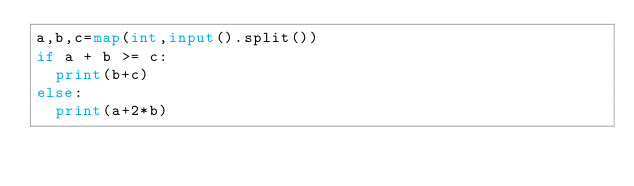<code> <loc_0><loc_0><loc_500><loc_500><_Python_>a,b,c=map(int,input().split())
if a + b >= c:
  print(b+c)
else:
  print(a+2*b)</code> 